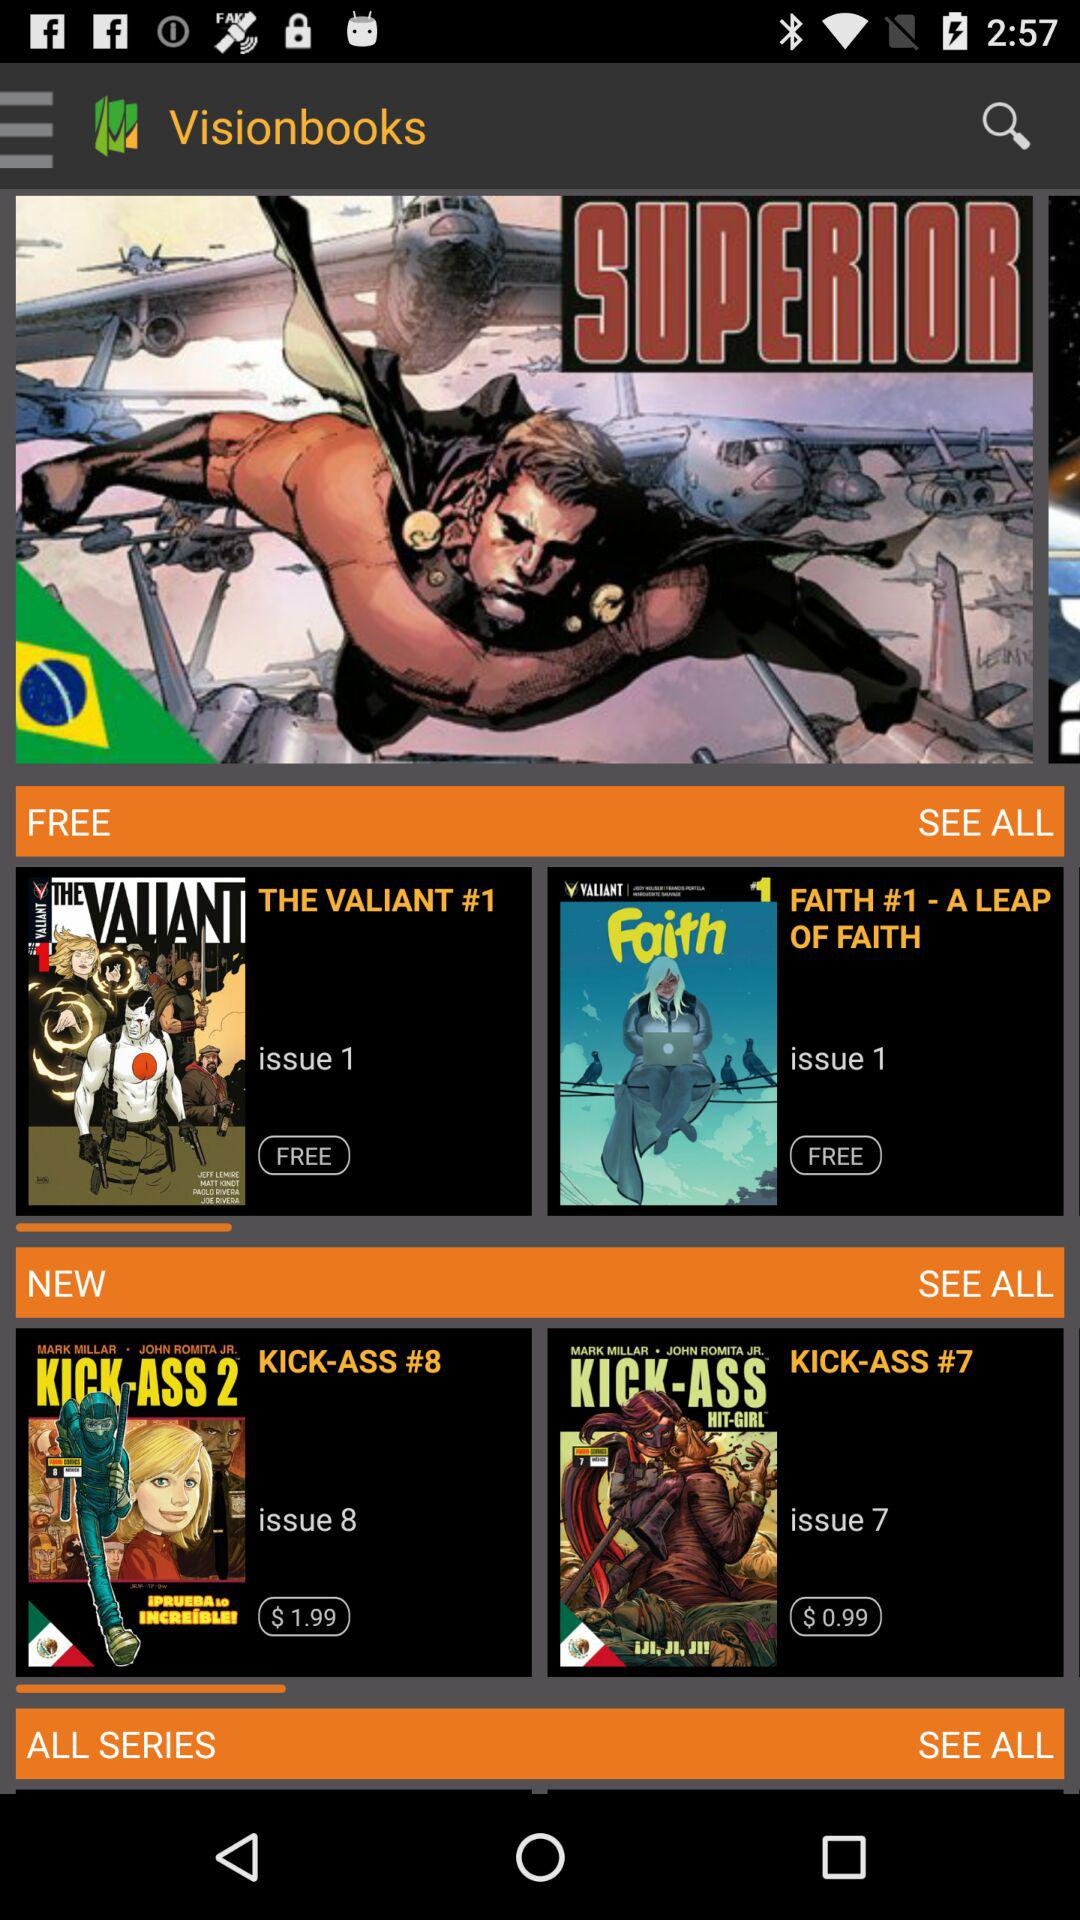What is the application name? The application name is "Visionbooks". 